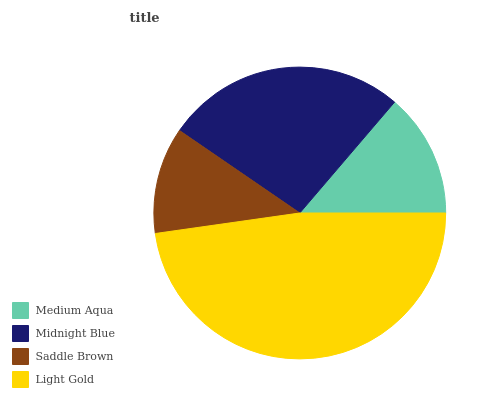Is Saddle Brown the minimum?
Answer yes or no. Yes. Is Light Gold the maximum?
Answer yes or no. Yes. Is Midnight Blue the minimum?
Answer yes or no. No. Is Midnight Blue the maximum?
Answer yes or no. No. Is Midnight Blue greater than Medium Aqua?
Answer yes or no. Yes. Is Medium Aqua less than Midnight Blue?
Answer yes or no. Yes. Is Medium Aqua greater than Midnight Blue?
Answer yes or no. No. Is Midnight Blue less than Medium Aqua?
Answer yes or no. No. Is Midnight Blue the high median?
Answer yes or no. Yes. Is Medium Aqua the low median?
Answer yes or no. Yes. Is Light Gold the high median?
Answer yes or no. No. Is Light Gold the low median?
Answer yes or no. No. 